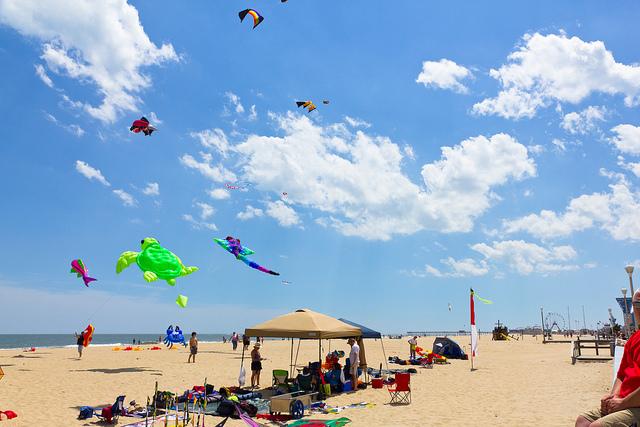What animal do the lower yellow kites look like?
Short answer required. Turtle. What kind of kites are these?
Short answer required. Animals. What color is the towel under the middle umbrella?
Be succinct. Blue. What sea creature is the big green kite?
Write a very short answer. Turtle. What color is the pail over the sand?
Concise answer only. Red. Which direction are the kites blowing into?
Short answer required. Left. How many kites are rainbow?
Quick response, please. 3. Are there clouds in the sky?
Keep it brief. Yes. 